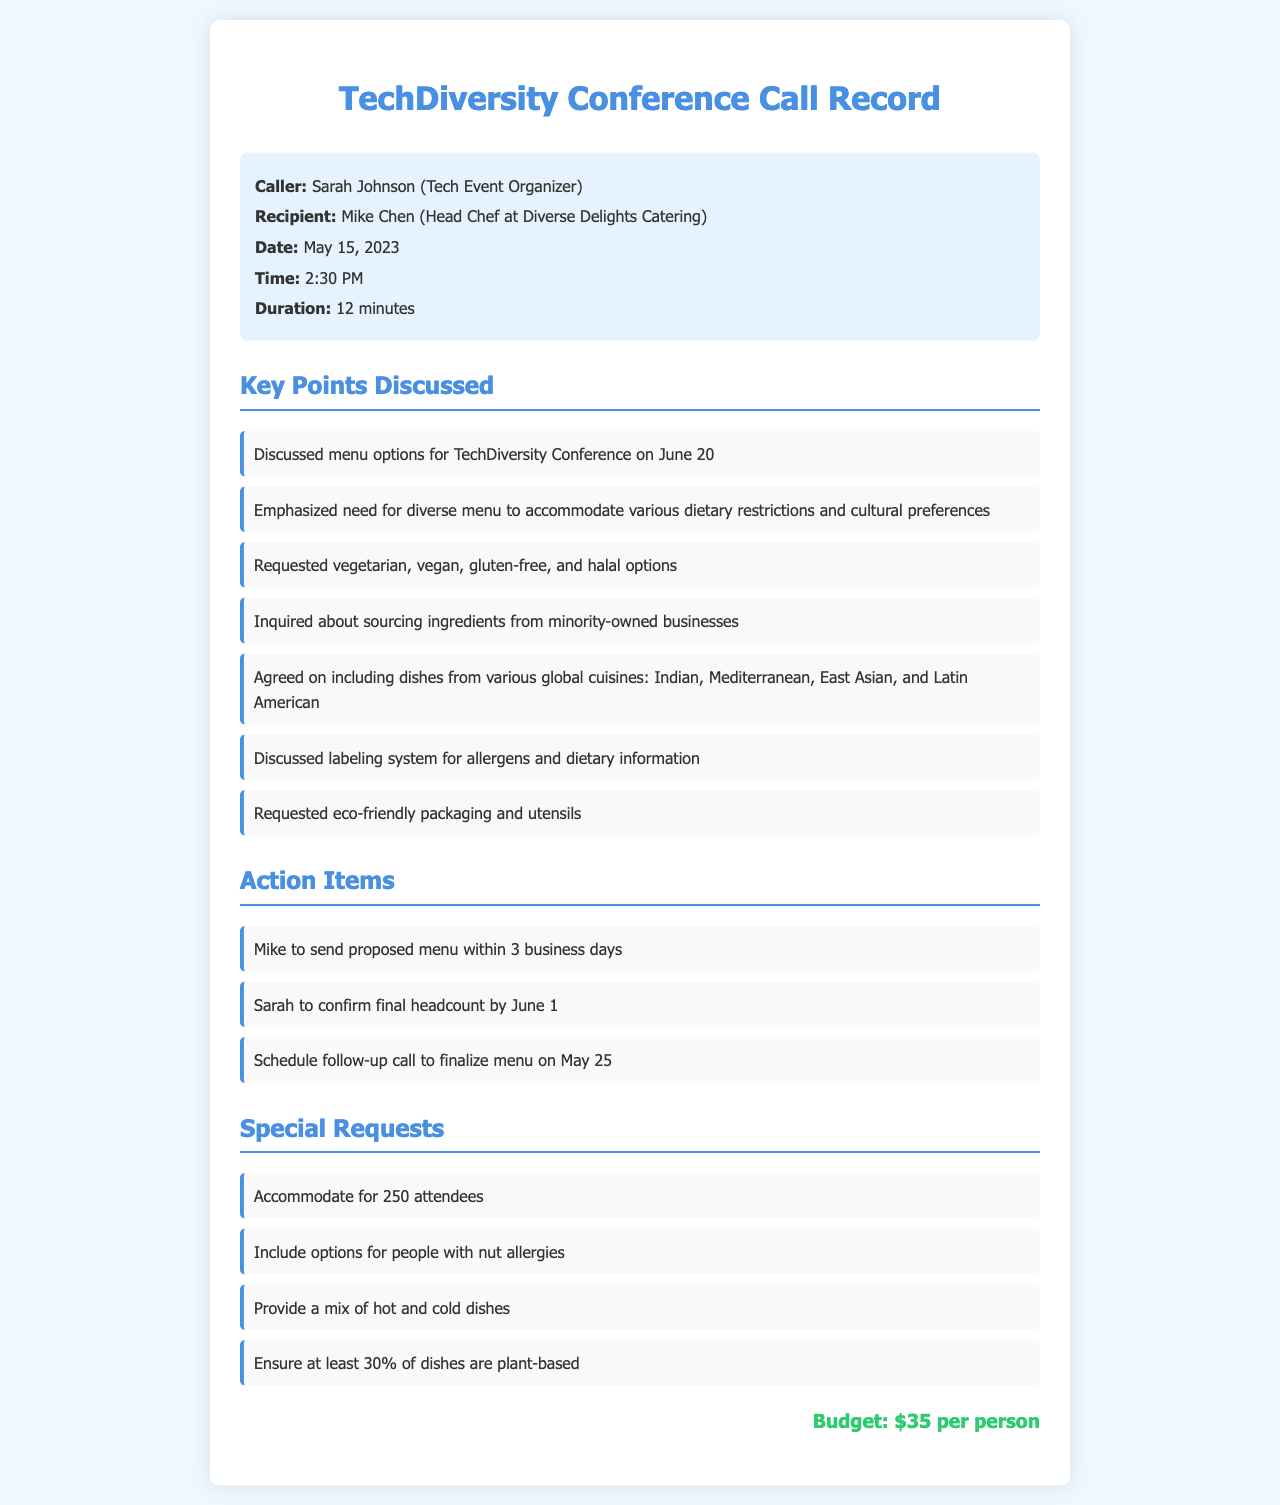What is the name of the caller? The caller is Sarah Johnson, the Tech Event Organizer.
Answer: Sarah Johnson Who is the recipient of the call? The recipient is Mike Chen, who is the Head Chef at Diverse Delights Catering.
Answer: Mike Chen When is the TechDiversity Conference scheduled? The conference is scheduled for June 20, 2023.
Answer: June 20 What dietary options were specifically requested during the call? The requested dietary options include vegetarian, vegan, gluten-free, and halal options.
Answer: Vegetarian, vegan, gluten-free, and halal What is the budget allocated per person for the catering service? The budget set for each attendee is $35.
Answer: $35 How many attendees is the catering service expected to accommodate? The expected number of attendees is 250.
Answer: 250 What type of cuisines will be included in the menu? The cuisines discussed include Indian, Mediterranean, East Asian, and Latin American.
Answer: Indian, Mediterranean, East Asian, and Latin American When is the follow-up call scheduled to finalize the menu? The follow-up call is scheduled for May 25, 2023.
Answer: May 25 What specific requirement is there regarding the plant-based dishes? There is a requirement that at least 30% of the dishes be plant-based.
Answer: 30% 